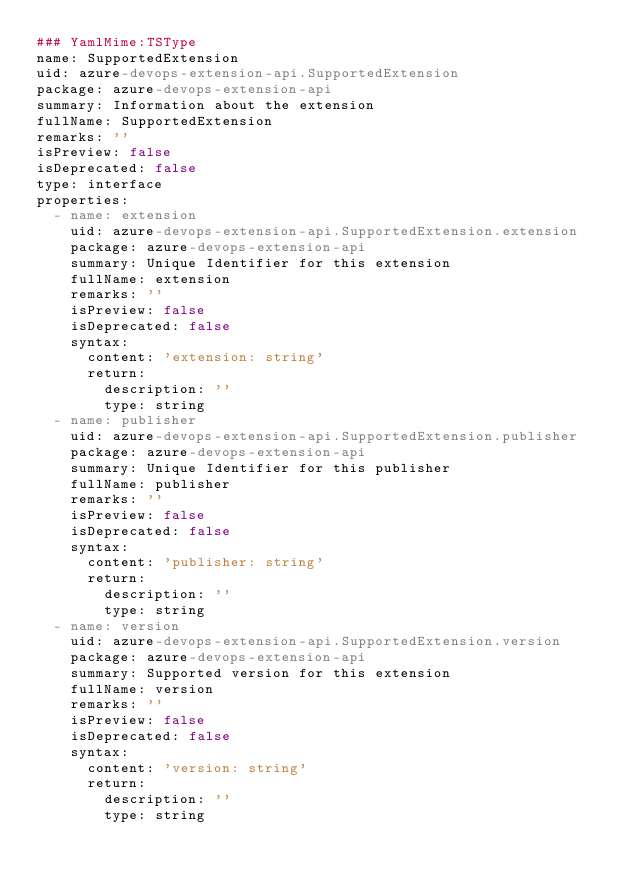<code> <loc_0><loc_0><loc_500><loc_500><_YAML_>### YamlMime:TSType
name: SupportedExtension
uid: azure-devops-extension-api.SupportedExtension
package: azure-devops-extension-api
summary: Information about the extension
fullName: SupportedExtension
remarks: ''
isPreview: false
isDeprecated: false
type: interface
properties:
  - name: extension
    uid: azure-devops-extension-api.SupportedExtension.extension
    package: azure-devops-extension-api
    summary: Unique Identifier for this extension
    fullName: extension
    remarks: ''
    isPreview: false
    isDeprecated: false
    syntax:
      content: 'extension: string'
      return:
        description: ''
        type: string
  - name: publisher
    uid: azure-devops-extension-api.SupportedExtension.publisher
    package: azure-devops-extension-api
    summary: Unique Identifier for this publisher
    fullName: publisher
    remarks: ''
    isPreview: false
    isDeprecated: false
    syntax:
      content: 'publisher: string'
      return:
        description: ''
        type: string
  - name: version
    uid: azure-devops-extension-api.SupportedExtension.version
    package: azure-devops-extension-api
    summary: Supported version for this extension
    fullName: version
    remarks: ''
    isPreview: false
    isDeprecated: false
    syntax:
      content: 'version: string'
      return:
        description: ''
        type: string
</code> 